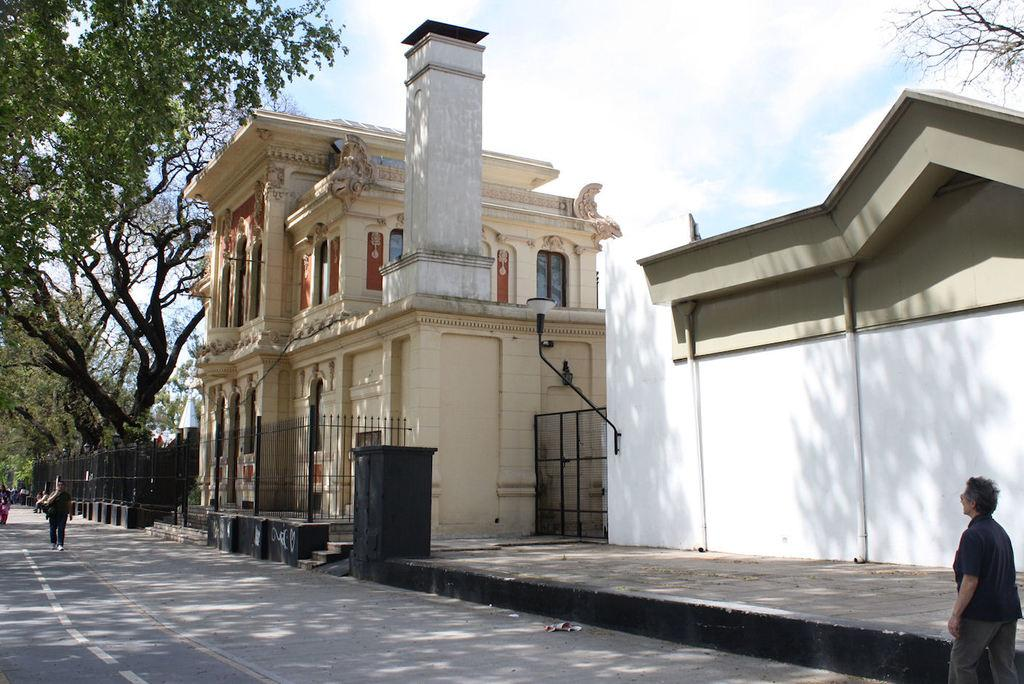What are the people in the image doing? The people in the image are walking on a road. What can be seen in the background of the image? There are houses, a railing, trees, and the sky visible in the background. Where is the store located in the image? There is no store present in the image. What type of sponge can be seen in the image? There is no sponge present in the image. 